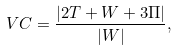Convert formula to latex. <formula><loc_0><loc_0><loc_500><loc_500>V C = \frac { | 2 T + W + 3 \Pi | } { | W | } ,</formula> 